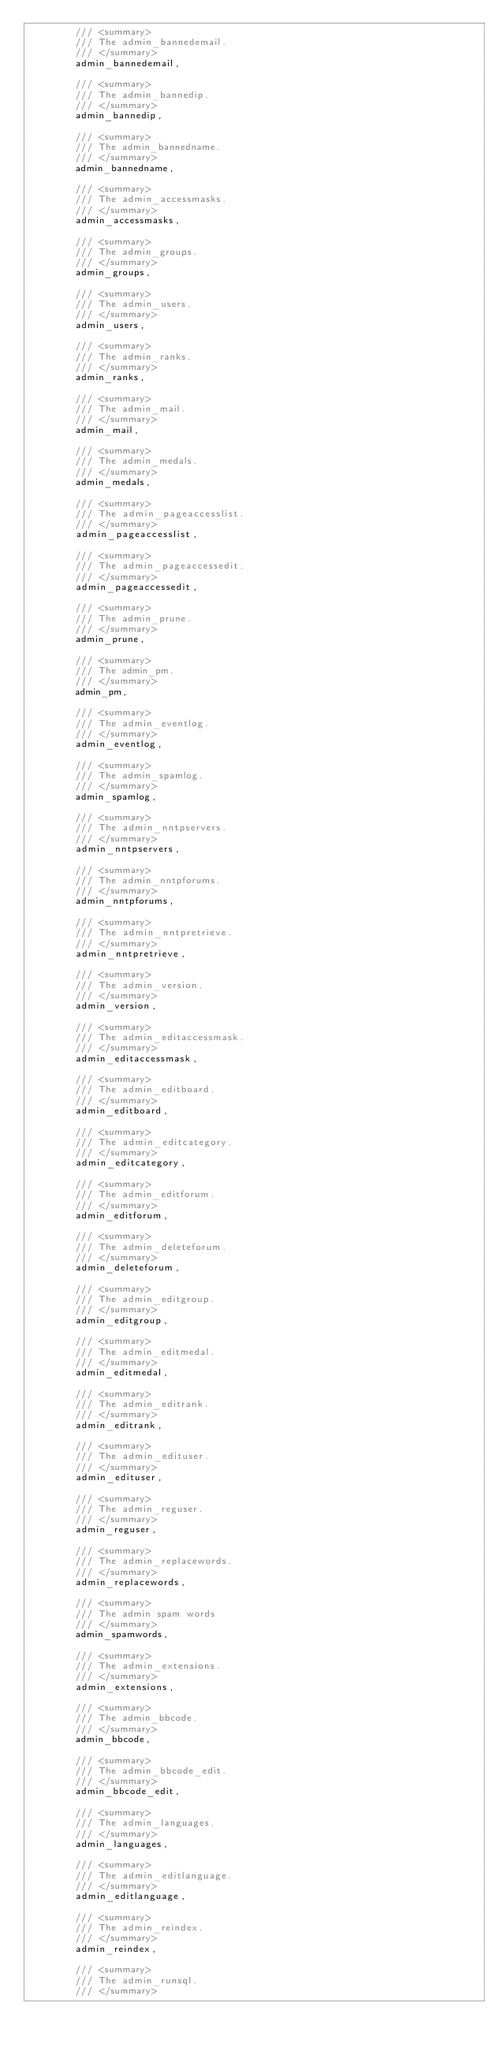Convert code to text. <code><loc_0><loc_0><loc_500><loc_500><_C#_>        /// <summary>
        /// The admin_bannedemail.
        /// </summary>
        admin_bannedemail,

        /// <summary>
        /// The admin_bannedip.
        /// </summary>
        admin_bannedip,

        /// <summary>
        /// The admin_bannedname.
        /// </summary>
        admin_bannedname,

        /// <summary>
        /// The admin_accessmasks.
        /// </summary>
        admin_accessmasks,

        /// <summary>
        /// The admin_groups.
        /// </summary>
        admin_groups,

        /// <summary>
        /// The admin_users.
        /// </summary>
        admin_users,

        /// <summary>
        /// The admin_ranks.
        /// </summary>
        admin_ranks,

        /// <summary>
        /// The admin_mail.
        /// </summary>
        admin_mail,

        /// <summary>
        /// The admin_medals.
        /// </summary>
        admin_medals,

        /// <summary>
        /// The admin_pageaccesslist.
        /// </summary>
        admin_pageaccesslist,

        /// <summary>
        /// The admin_pageaccessedit.
        /// </summary>
        admin_pageaccessedit,

        /// <summary>
        /// The admin_prune.
        /// </summary>
        admin_prune,

        /// <summary>
        /// The admin_pm.
        /// </summary>
        admin_pm,

        /// <summary>
        /// The admin_eventlog.
        /// </summary>
        admin_eventlog,

        /// <summary>
        /// The admin_spamlog.
        /// </summary>
        admin_spamlog,

        /// <summary>
        /// The admin_nntpservers.
        /// </summary>
        admin_nntpservers,

        /// <summary>
        /// The admin_nntpforums.
        /// </summary>
        admin_nntpforums,

        /// <summary>
        /// The admin_nntpretrieve.
        /// </summary>
        admin_nntpretrieve,

        /// <summary>
        /// The admin_version.
        /// </summary>
        admin_version,

        /// <summary>
        /// The admin_editaccessmask.
        /// </summary>
        admin_editaccessmask,

        /// <summary>
        /// The admin_editboard.
        /// </summary>
        admin_editboard,

        /// <summary>
        /// The admin_editcategory.
        /// </summary>
        admin_editcategory,

        /// <summary>
        /// The admin_editforum.
        /// </summary>
        admin_editforum,

        /// <summary>
        /// The admin_deleteforum.
        /// </summary>
        admin_deleteforum,

        /// <summary>
        /// The admin_editgroup.
        /// </summary>
        admin_editgroup,

        /// <summary>
        /// The admin_editmedal.
        /// </summary>
        admin_editmedal,

        /// <summary>
        /// The admin_editrank.
        /// </summary>
        admin_editrank,

        /// <summary>
        /// The admin_edituser.
        /// </summary>
        admin_edituser,

        /// <summary>
        /// The admin_reguser.
        /// </summary>
        admin_reguser,

        /// <summary>
        /// The admin_replacewords.
        /// </summary>
        admin_replacewords,

        /// <summary>
        /// The admin spam words
        /// </summary>
        admin_spamwords,

        /// <summary>
        /// The admin_extensions.
        /// </summary>
        admin_extensions,

        /// <summary>
        /// The admin_bbcode.
        /// </summary>
        admin_bbcode,

        /// <summary>
        /// The admin_bbcode_edit.
        /// </summary>
        admin_bbcode_edit,

        /// <summary>
        /// The admin_languages.
        /// </summary>
        admin_languages,

        /// <summary>
        /// The admin_editlanguage.
        /// </summary>
        admin_editlanguage,

        /// <summary>
        /// The admin_reindex.
        /// </summary>
        admin_reindex,

        /// <summary>
        /// The admin_runsql.
        /// </summary></code> 